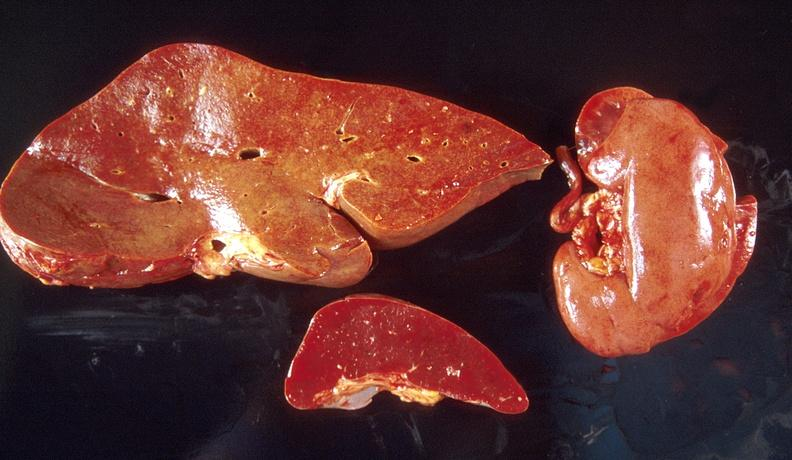does this image show amyloid, liver, spleen, and kidney?
Answer the question using a single word or phrase. Yes 